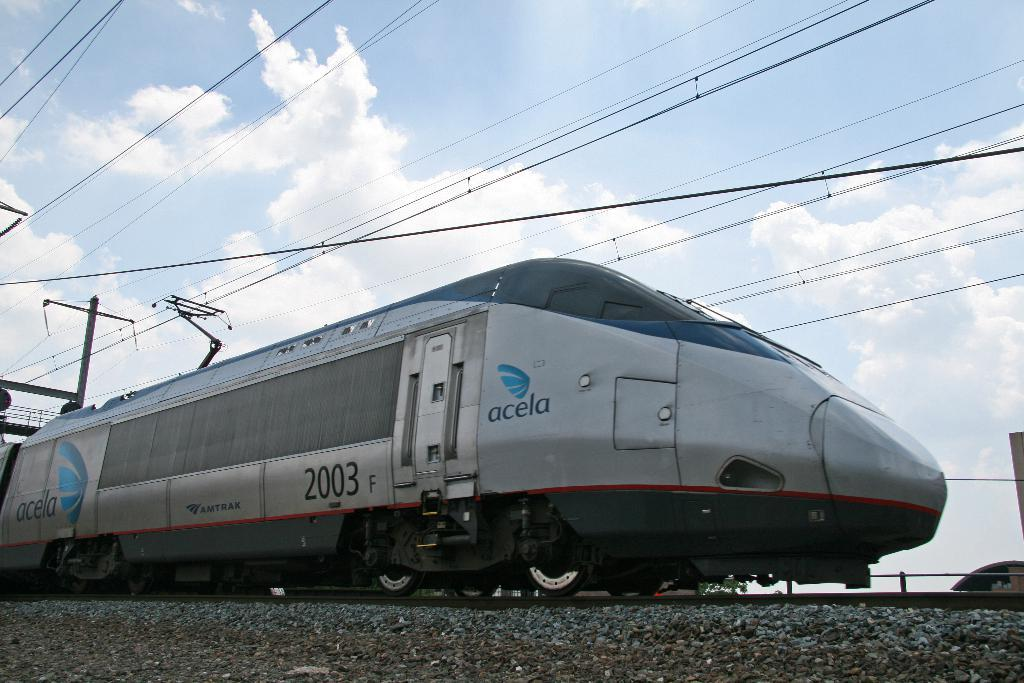What is the main subject in the center of the image? There is a train in the center of the image. What can be seen at the top side of the image? There are wires at the top side of the image. What is visible in the background of the image? The sky is visible in the background of the image. What type of lipstick is being applied by the train in the image? There is no lipstick or person applying it in the image; it features a train and wires. 